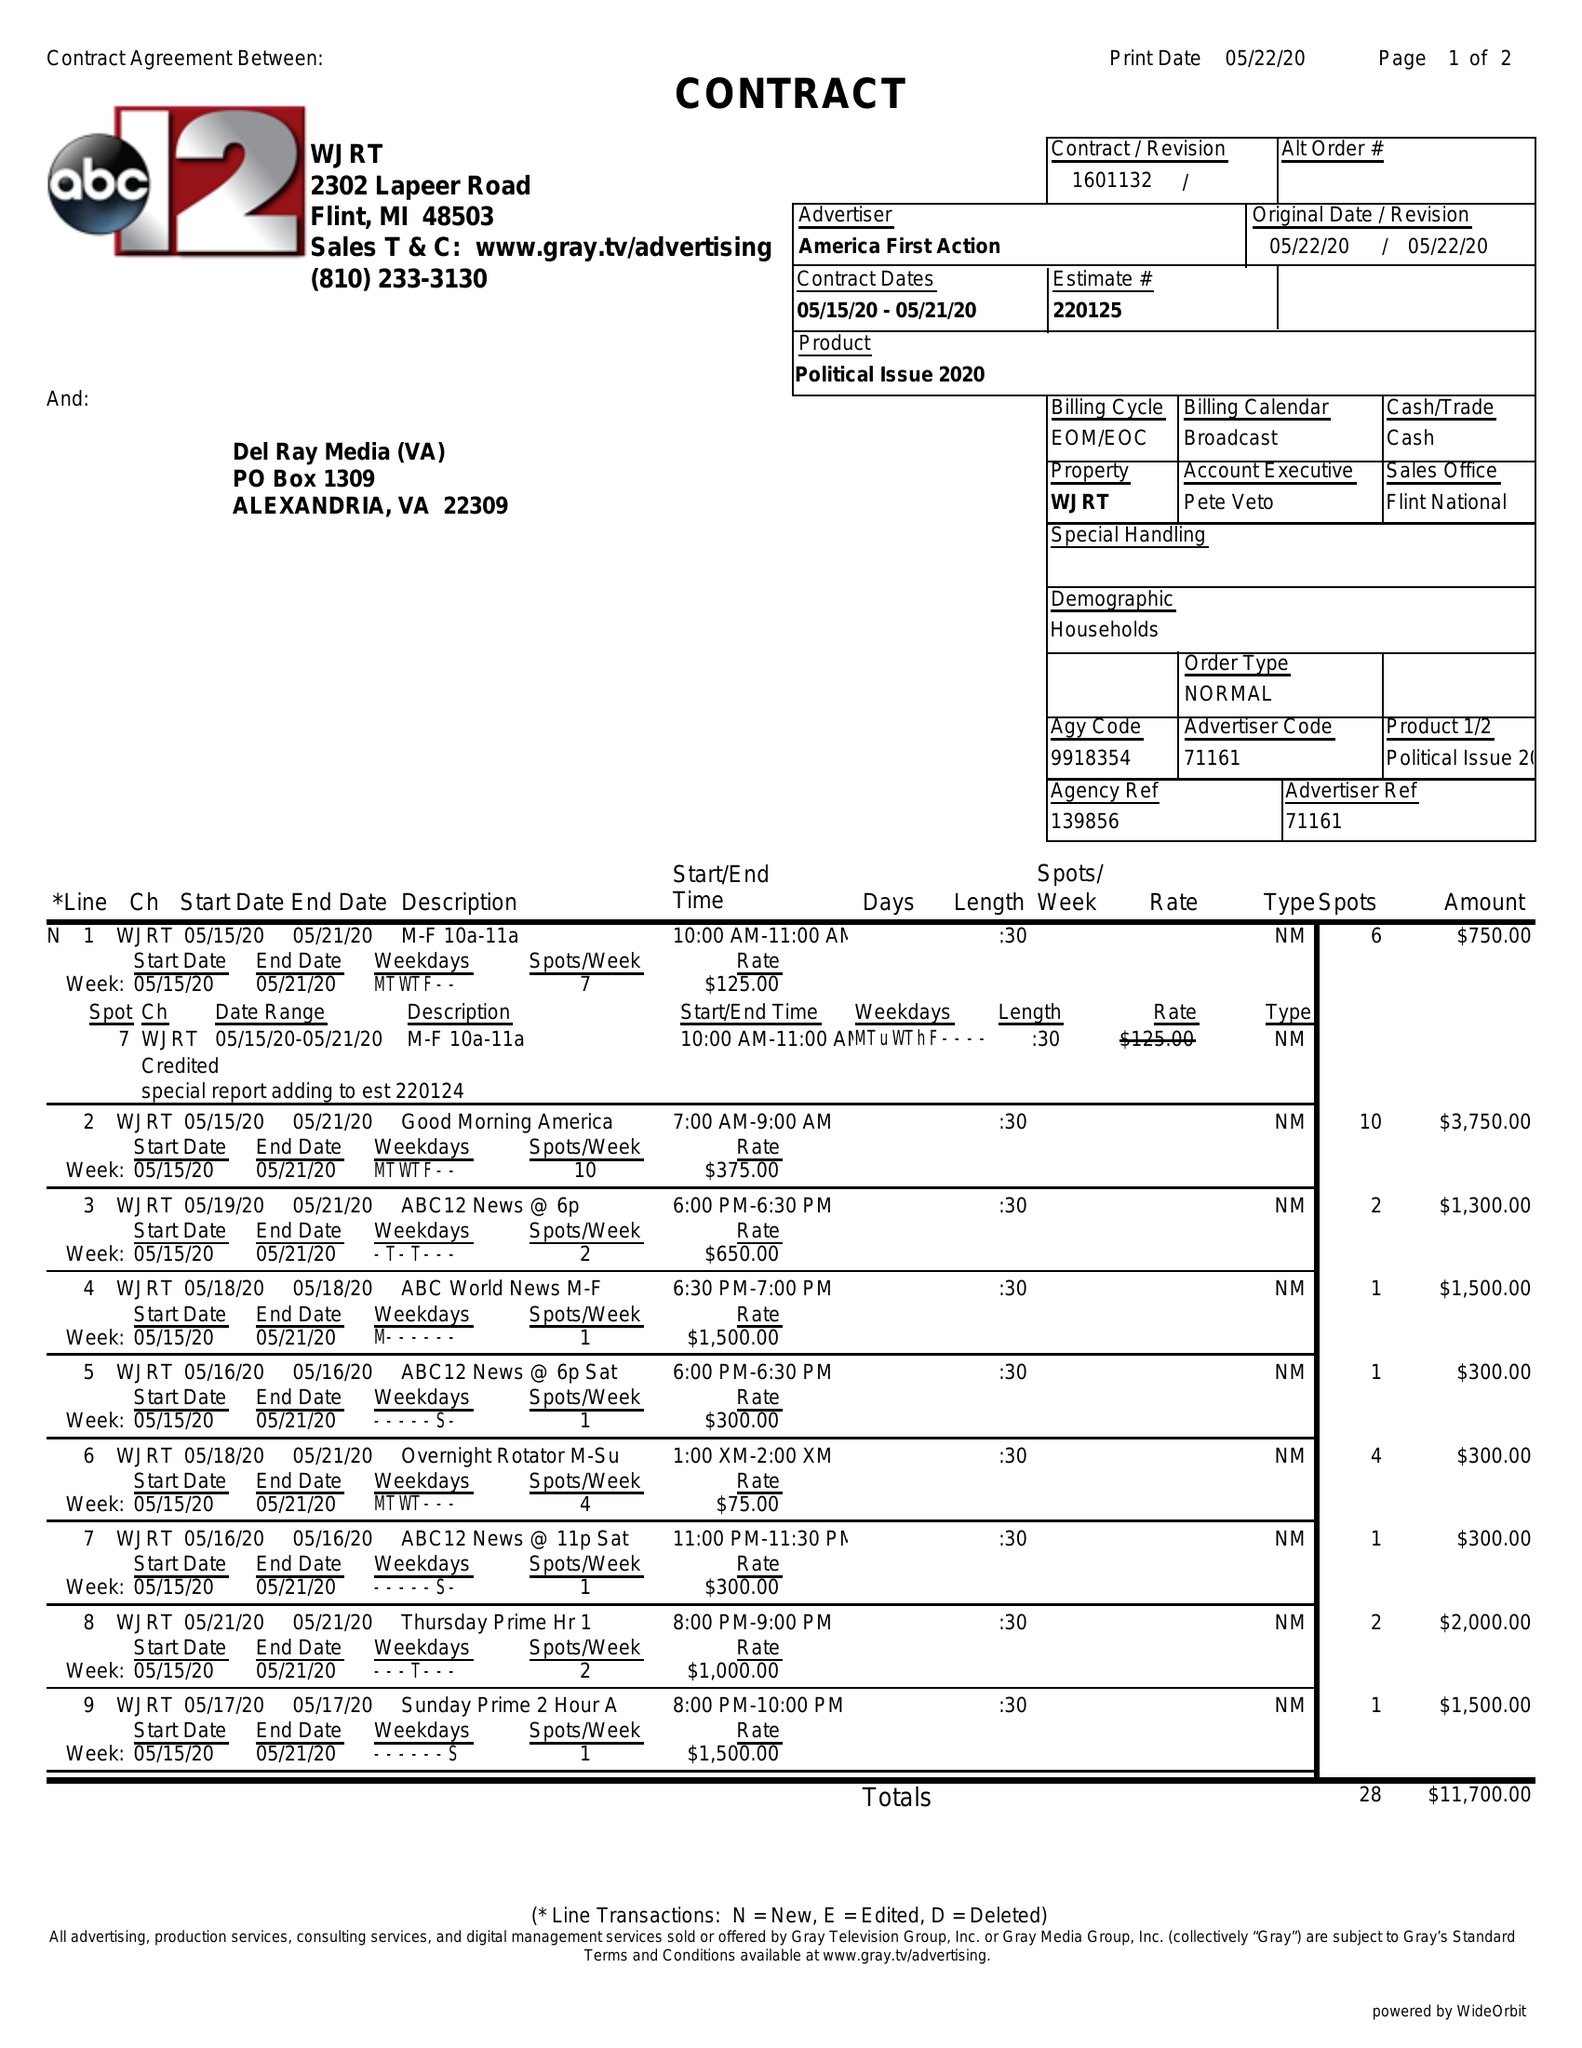What is the value for the flight_to?
Answer the question using a single word or phrase. 05/21/20 